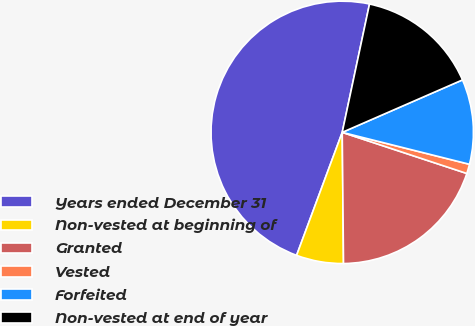<chart> <loc_0><loc_0><loc_500><loc_500><pie_chart><fcel>Years ended December 31<fcel>Non-vested at beginning of<fcel>Granted<fcel>Vested<fcel>Forfeited<fcel>Non-vested at end of year<nl><fcel>47.68%<fcel>5.81%<fcel>19.77%<fcel>1.16%<fcel>10.46%<fcel>15.12%<nl></chart> 